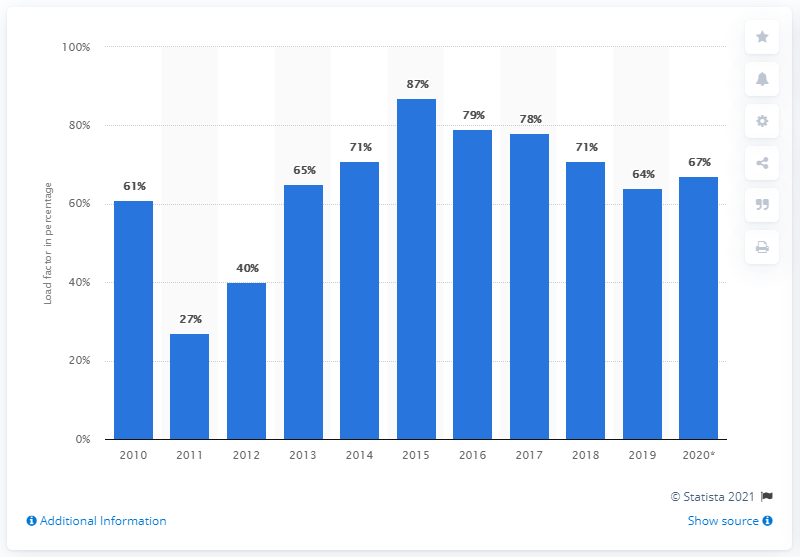List a handful of essential elements in this visual. In 2020, the electricity load factor from plant biomass in the UK was 67%. 